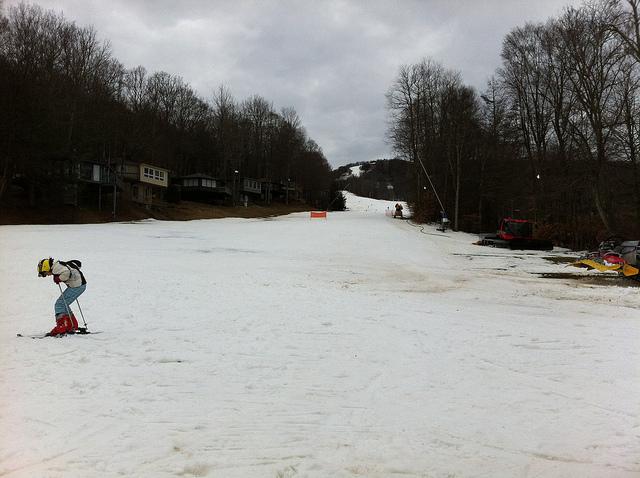What is the lady holding?
Concise answer only. Ski poles. Is the snow dirty?
Answer briefly. Yes. What season is this?
Give a very brief answer. Winter. Is this downhill skiing?
Concise answer only. No. What color are his pants?
Keep it brief. Blue. Is the season likely summer?
Answer briefly. No. 